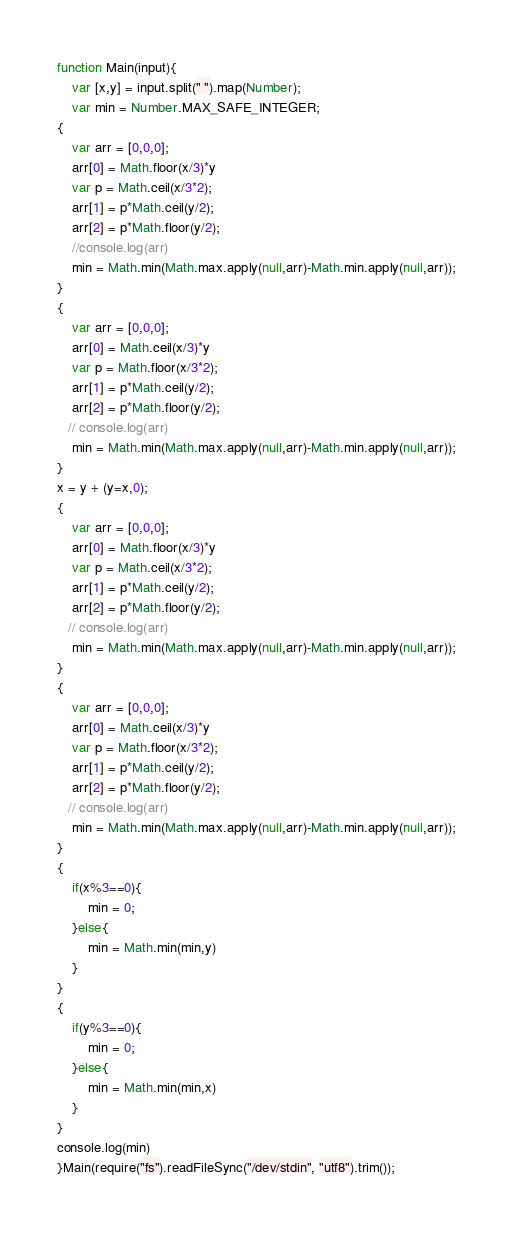Convert code to text. <code><loc_0><loc_0><loc_500><loc_500><_JavaScript_>function Main(input){
    var [x,y] = input.split(" ").map(Number);
    var min = Number.MAX_SAFE_INTEGER;
{
    var arr = [0,0,0];
    arr[0] = Math.floor(x/3)*y
    var p = Math.ceil(x/3*2);
    arr[1] = p*Math.ceil(y/2);
    arr[2] = p*Math.floor(y/2);
    //console.log(arr)
    min = Math.min(Math.max.apply(null,arr)-Math.min.apply(null,arr));
}
{
    var arr = [0,0,0];
    arr[0] = Math.ceil(x/3)*y
    var p = Math.floor(x/3*2);
    arr[1] = p*Math.ceil(y/2);
    arr[2] = p*Math.floor(y/2);
   // console.log(arr)
    min = Math.min(Math.max.apply(null,arr)-Math.min.apply(null,arr));
}
x = y + (y=x,0);
{
    var arr = [0,0,0];
    arr[0] = Math.floor(x/3)*y
    var p = Math.ceil(x/3*2);
    arr[1] = p*Math.ceil(y/2);
    arr[2] = p*Math.floor(y/2);
   // console.log(arr)
    min = Math.min(Math.max.apply(null,arr)-Math.min.apply(null,arr));
}
{
    var arr = [0,0,0];
    arr[0] = Math.ceil(x/3)*y
    var p = Math.floor(x/3*2);
    arr[1] = p*Math.ceil(y/2);
    arr[2] = p*Math.floor(y/2);
   // console.log(arr)
    min = Math.min(Math.max.apply(null,arr)-Math.min.apply(null,arr));
}
{
    if(x%3==0){
        min = 0;
    }else{
        min = Math.min(min,y)
    }
}
{
    if(y%3==0){
        min = 0;
    }else{
        min = Math.min(min,x)
    }
}
console.log(min)
}Main(require("fs").readFileSync("/dev/stdin", "utf8").trim());
</code> 